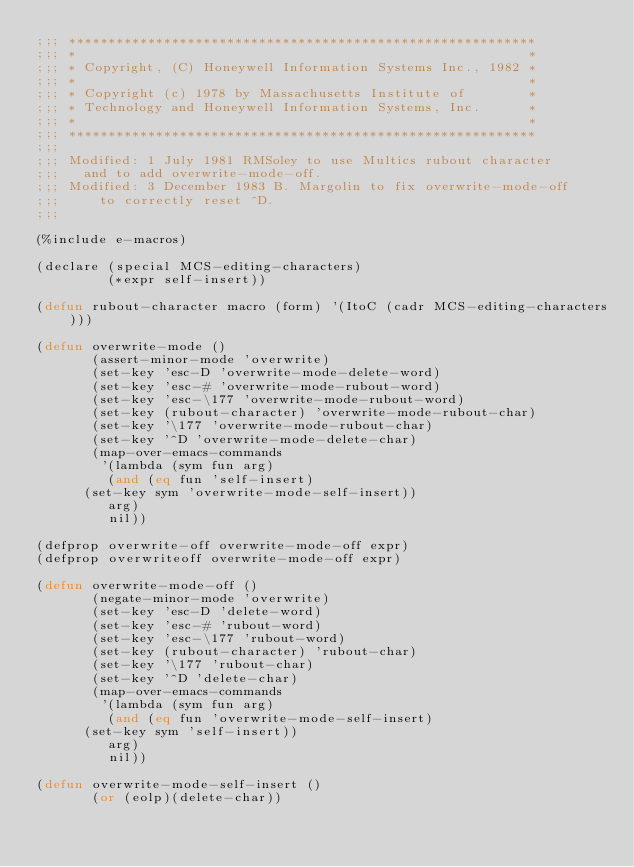<code> <loc_0><loc_0><loc_500><loc_500><_Lisp_>;;; ***********************************************************
;;; *                                                         *
;;; * Copyright, (C) Honeywell Information Systems Inc., 1982 *
;;; *                                                         *
;;; * Copyright (c) 1978 by Massachusetts Institute of        *
;;; * Technology and Honeywell Information Systems, Inc.      *
;;; *                                                         *
;;; ***********************************************************
;;;
;;; Modified: 1 July 1981 RMSoley to use Multics rubout character
;;;		and to add overwrite-mode-off.
;;; Modified: 3 December 1983 B. Margolin to fix overwrite-mode-off
;;;	    to correctly reset ^D.
;;;

(%include e-macros)

(declare (special MCS-editing-characters)
         (*expr self-insert))

(defun rubout-character macro (form) '(ItoC (cadr MCS-editing-characters)))

(defun overwrite-mode ()
       (assert-minor-mode 'overwrite)
       (set-key 'esc-D 'overwrite-mode-delete-word)
       (set-key 'esc-# 'overwrite-mode-rubout-word)
       (set-key 'esc-\177 'overwrite-mode-rubout-word)
       (set-key (rubout-character) 'overwrite-mode-rubout-char)
       (set-key '\177 'overwrite-mode-rubout-char)
       (set-key '^D 'overwrite-mode-delete-char)
       (map-over-emacs-commands
        '(lambda (sym fun arg)
	       (and (eq fun 'self-insert)
		  (set-key sym 'overwrite-mode-self-insert))
	       arg)
         nil))

(defprop overwrite-off overwrite-mode-off expr)
(defprop overwriteoff overwrite-mode-off expr)

(defun overwrite-mode-off ()
       (negate-minor-mode 'overwrite)
       (set-key 'esc-D 'delete-word)
       (set-key 'esc-# 'rubout-word)
       (set-key 'esc-\177 'rubout-word)
       (set-key (rubout-character) 'rubout-char)
       (set-key '\177 'rubout-char)
       (set-key '^D 'delete-char)
       (map-over-emacs-commands
        '(lambda (sym fun arg)
	       (and (eq fun 'overwrite-mode-self-insert)
		  (set-key sym 'self-insert))
	       arg)
         nil))

(defun overwrite-mode-self-insert ()
       (or (eolp)(delete-char))</code> 